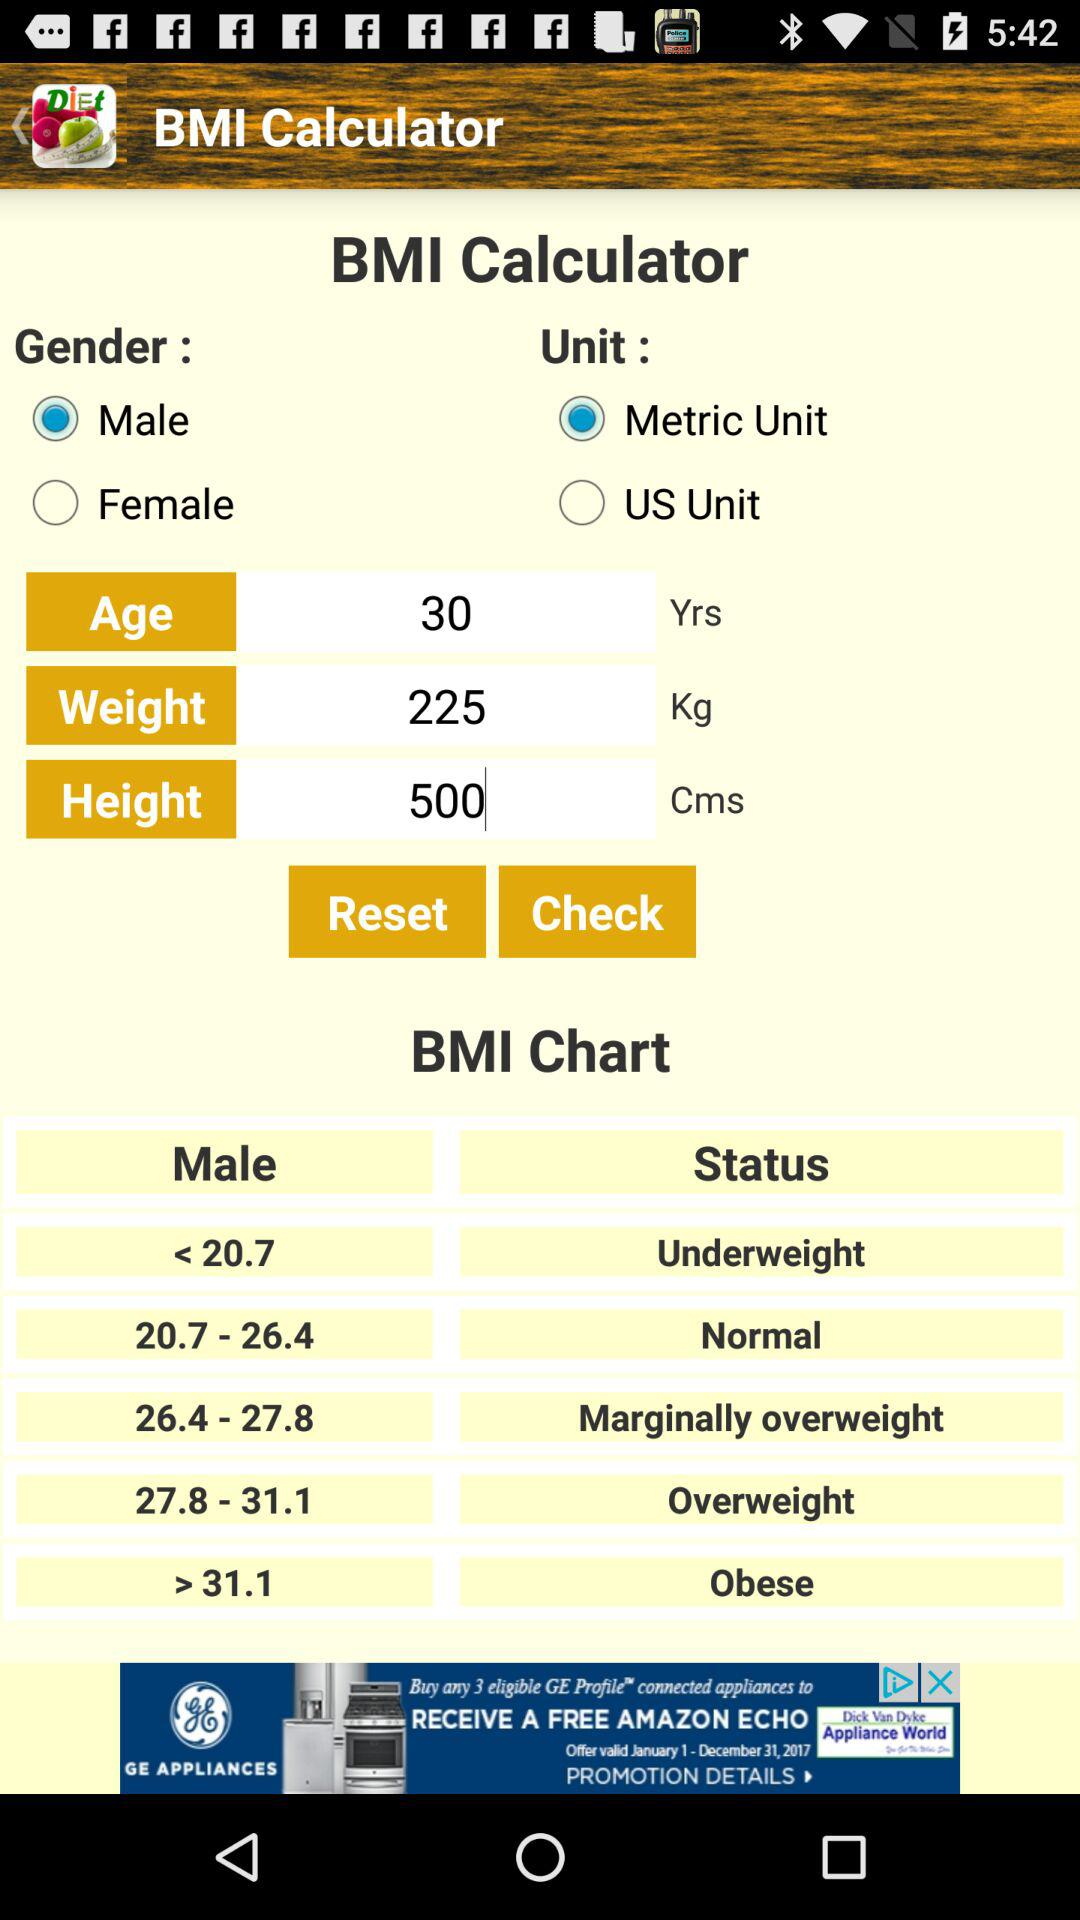What is the height? The height is 500 cm. 